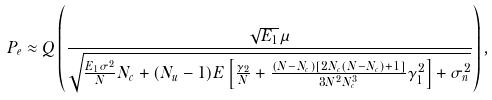Convert formula to latex. <formula><loc_0><loc_0><loc_500><loc_500>P _ { e } \approx Q \left ( \frac { \sqrt { E _ { 1 } } \mu } { \sqrt { \frac { E _ { 1 } \sigma ^ { 2 } } { N } N _ { c } + ( N _ { u } - 1 ) E \left [ \frac { \gamma _ { 2 } } { N } + \frac { ( N - N _ { c } ) [ 2 N _ { c } ( N - N _ { c } ) + 1 ] } { 3 N ^ { 2 } N _ { c } ^ { 3 } } \gamma _ { 1 } ^ { 2 } \right ] + \sigma _ { n } ^ { 2 } } } \right ) ,</formula> 